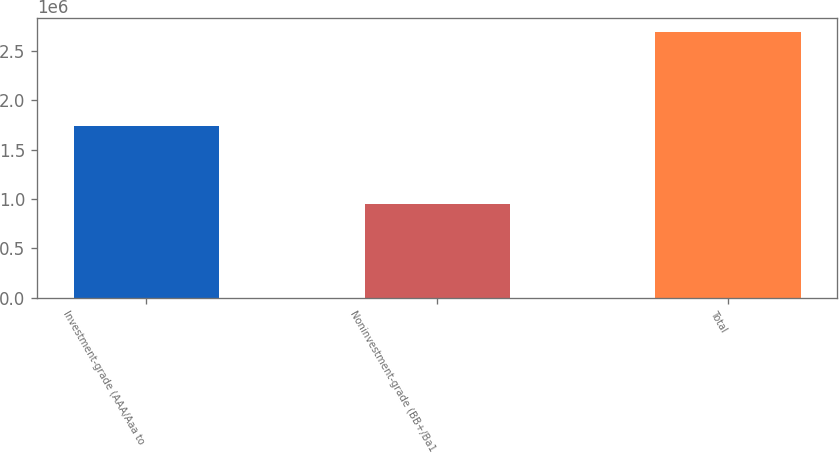Convert chart to OTSL. <chart><loc_0><loc_0><loc_500><loc_500><bar_chart><fcel>Investment-grade (AAA/Aaa to<fcel>Noninvestment-grade (BB+/Ba1<fcel>Total<nl><fcel>1.74328e+06<fcel>950619<fcel>2.6939e+06<nl></chart> 